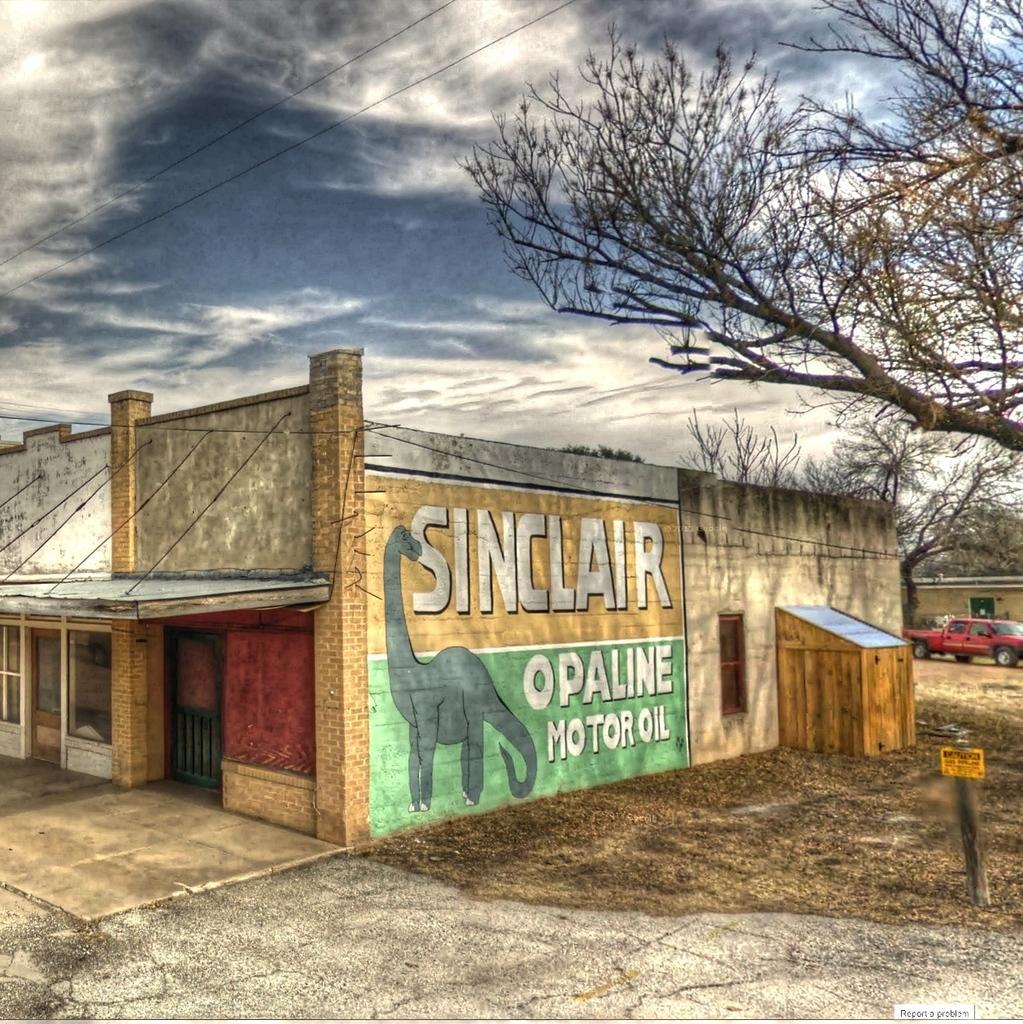Can you describe this image briefly? In this picture we can see buildings, pole, vehicle on the ground, trees, painting on the wall, some objects and in the background we can see the sky with clouds. 